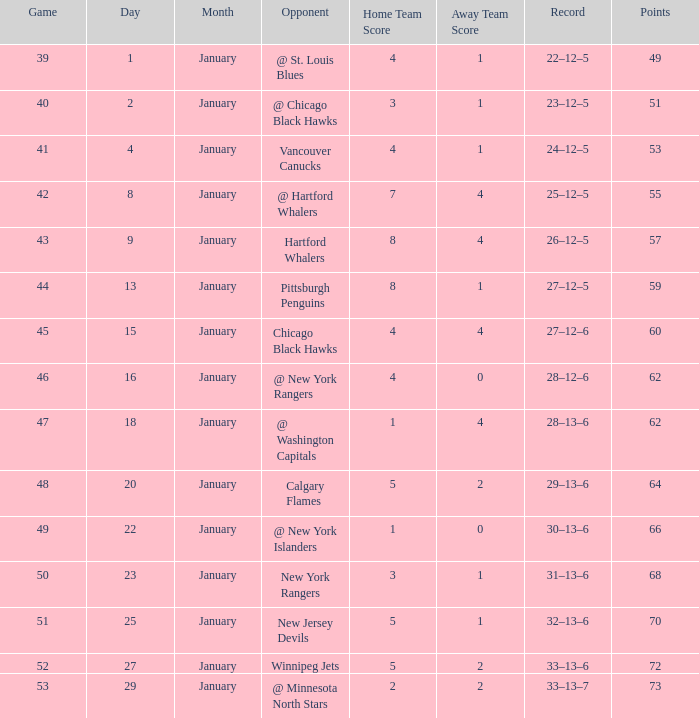Which January has a Score of 7–4, and a Game smaller than 42? None. 